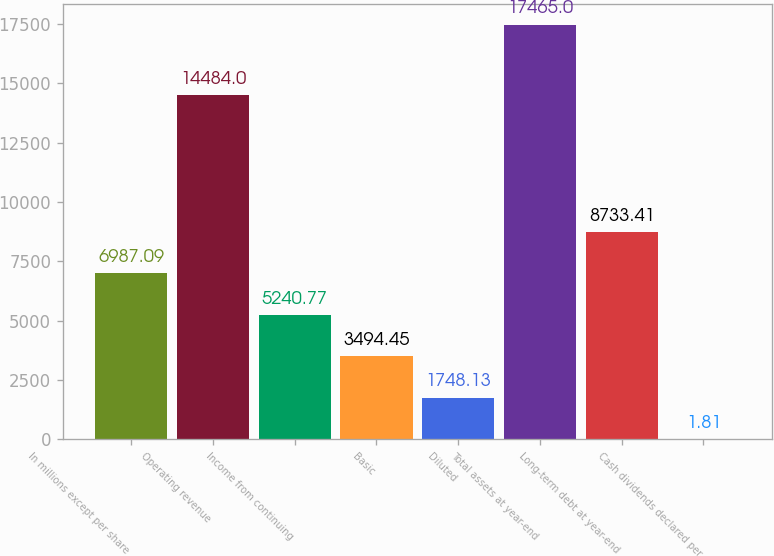<chart> <loc_0><loc_0><loc_500><loc_500><bar_chart><fcel>In millions except per share<fcel>Operating revenue<fcel>Income from continuing<fcel>Basic<fcel>Diluted<fcel>Total assets at year-end<fcel>Long-term debt at year-end<fcel>Cash dividends declared per<nl><fcel>6987.09<fcel>14484<fcel>5240.77<fcel>3494.45<fcel>1748.13<fcel>17465<fcel>8733.41<fcel>1.81<nl></chart> 